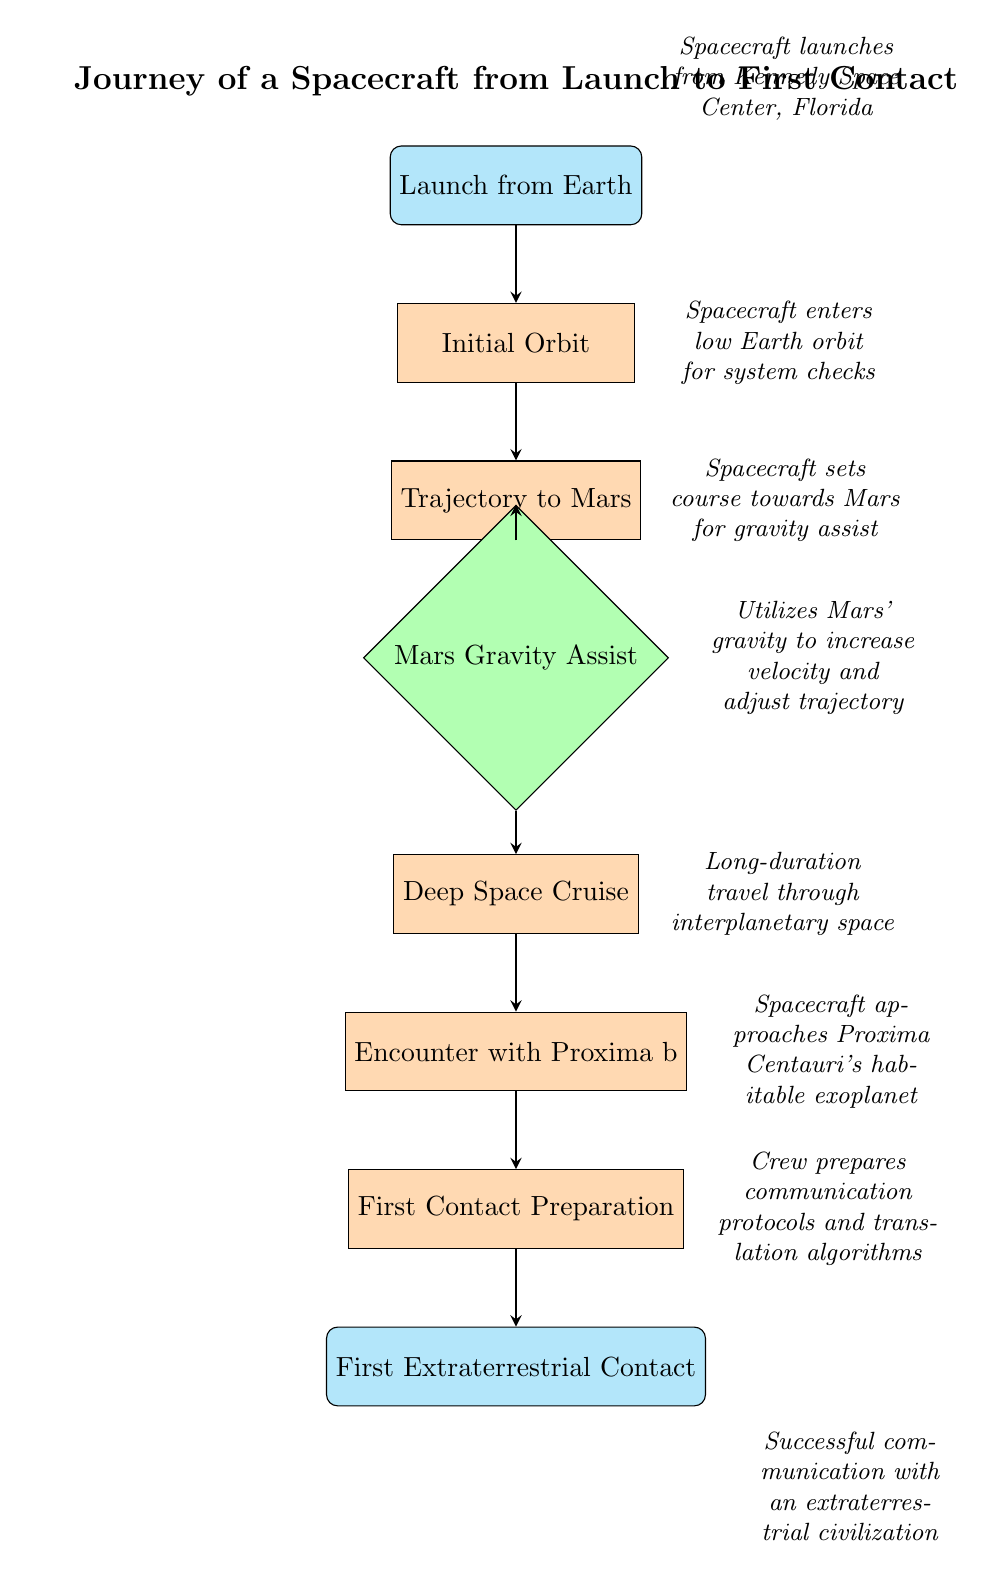What is the first step in the journey? The first step, as indicated by the top node in the diagram, is "Launch from Earth." This node is directly at the beginning of the flow chart.
Answer: Launch from Earth How many total nodes are in the diagram? By counting each node visually from the diagram, there are 8 distinct steps or nodes in the journey.
Answer: 8 What is the last step before making first contact? The last step before the successful communication is "First Contact Preparation," positioned directly before "First Extraterrestrial Contact."
Answer: First Contact Preparation What action contributes to increasing the spacecraft's velocity? The action that increases the spacecraft's velocity is "Mars Gravity Assist," where it utilizes Mars' gravity to gain speed.
Answer: Mars Gravity Assist Which node follows the "Deep Space Cruise"? Following "Deep Space Cruise," the diagram indicates the subsequent node is "Encounter with Proxima b," which is the next step in the journey.
Answer: Encounter with Proxima b Which two nodes are directly connected to the "Encounter with Proxima b"? The nodes directly connected to "Encounter with Proxima b" are "Deep Space Cruise" (before) and "First Contact Preparation" (after), showing the journey flow.
Answer: Deep Space Cruise and First Contact Preparation What is the purpose of the "First Contact Preparation"? The purpose of this node is to prepare communication protocols and translation algorithms necessary for interacting with extraterrestrial life.
Answer: Prepare communication protocols and translation algorithms In which phase does the spacecraft set its course towards Mars? The spacecraft sets course towards Mars during the "Trajectory to Mars" phase, which is a critical navigation step in the journey.
Answer: Trajectory to Mars 